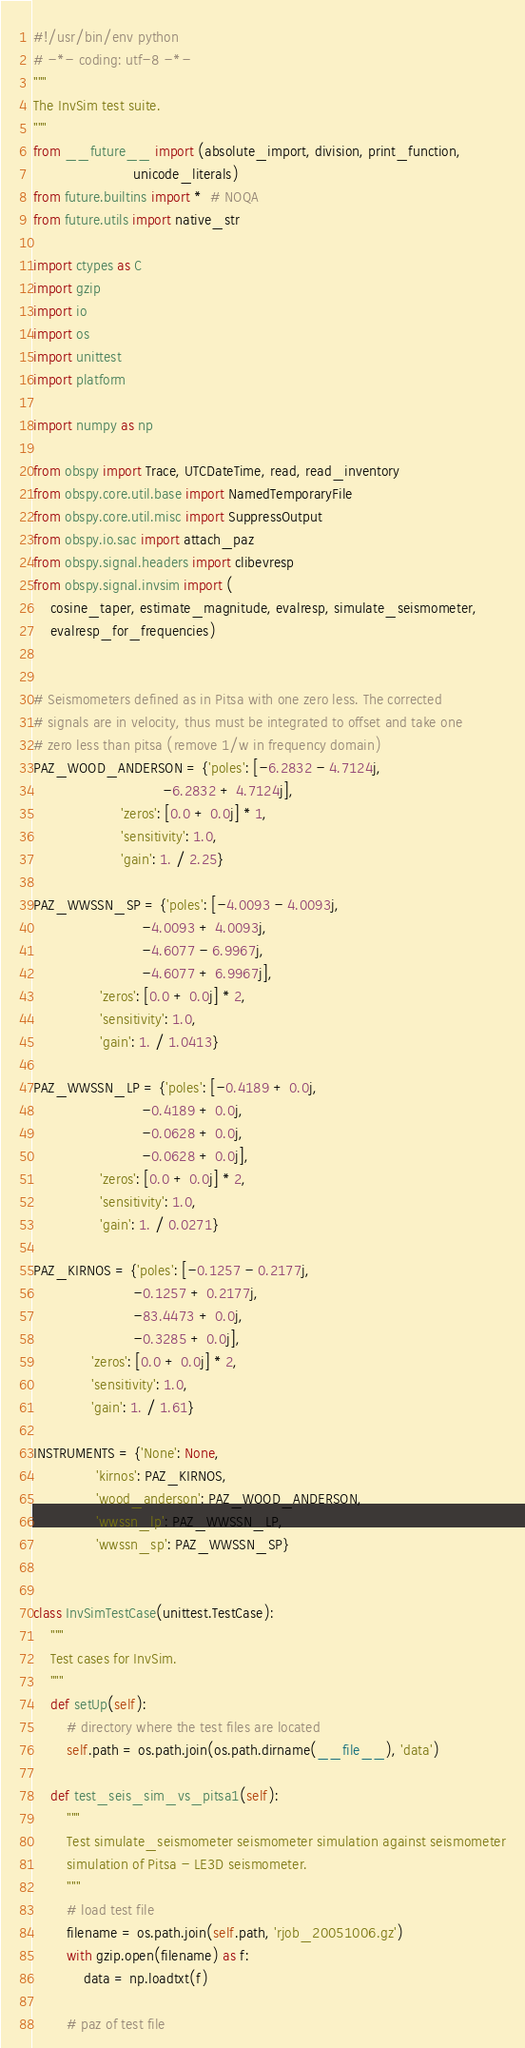<code> <loc_0><loc_0><loc_500><loc_500><_Python_>#!/usr/bin/env python
# -*- coding: utf-8 -*-
"""
The InvSim test suite.
"""
from __future__ import (absolute_import, division, print_function,
                        unicode_literals)
from future.builtins import *  # NOQA
from future.utils import native_str

import ctypes as C
import gzip
import io
import os
import unittest
import platform

import numpy as np

from obspy import Trace, UTCDateTime, read, read_inventory
from obspy.core.util.base import NamedTemporaryFile
from obspy.core.util.misc import SuppressOutput
from obspy.io.sac import attach_paz
from obspy.signal.headers import clibevresp
from obspy.signal.invsim import (
    cosine_taper, estimate_magnitude, evalresp, simulate_seismometer,
    evalresp_for_frequencies)


# Seismometers defined as in Pitsa with one zero less. The corrected
# signals are in velocity, thus must be integrated to offset and take one
# zero less than pitsa (remove 1/w in frequency domain)
PAZ_WOOD_ANDERSON = {'poles': [-6.2832 - 4.7124j,
                               -6.2832 + 4.7124j],
                     'zeros': [0.0 + 0.0j] * 1,
                     'sensitivity': 1.0,
                     'gain': 1. / 2.25}

PAZ_WWSSN_SP = {'poles': [-4.0093 - 4.0093j,
                          -4.0093 + 4.0093j,
                          -4.6077 - 6.9967j,
                          -4.6077 + 6.9967j],
                'zeros': [0.0 + 0.0j] * 2,
                'sensitivity': 1.0,
                'gain': 1. / 1.0413}

PAZ_WWSSN_LP = {'poles': [-0.4189 + 0.0j,
                          -0.4189 + 0.0j,
                          -0.0628 + 0.0j,
                          -0.0628 + 0.0j],
                'zeros': [0.0 + 0.0j] * 2,
                'sensitivity': 1.0,
                'gain': 1. / 0.0271}

PAZ_KIRNOS = {'poles': [-0.1257 - 0.2177j,
                        -0.1257 + 0.2177j,
                        -83.4473 + 0.0j,
                        -0.3285 + 0.0j],
              'zeros': [0.0 + 0.0j] * 2,
              'sensitivity': 1.0,
              'gain': 1. / 1.61}

INSTRUMENTS = {'None': None,
               'kirnos': PAZ_KIRNOS,
               'wood_anderson': PAZ_WOOD_ANDERSON,
               'wwssn_lp': PAZ_WWSSN_LP,
               'wwssn_sp': PAZ_WWSSN_SP}


class InvSimTestCase(unittest.TestCase):
    """
    Test cases for InvSim.
    """
    def setUp(self):
        # directory where the test files are located
        self.path = os.path.join(os.path.dirname(__file__), 'data')

    def test_seis_sim_vs_pitsa1(self):
        """
        Test simulate_seismometer seismometer simulation against seismometer
        simulation of Pitsa - LE3D seismometer.
        """
        # load test file
        filename = os.path.join(self.path, 'rjob_20051006.gz')
        with gzip.open(filename) as f:
            data = np.loadtxt(f)

        # paz of test file</code> 